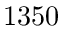<formula> <loc_0><loc_0><loc_500><loc_500>1 3 5 0</formula> 